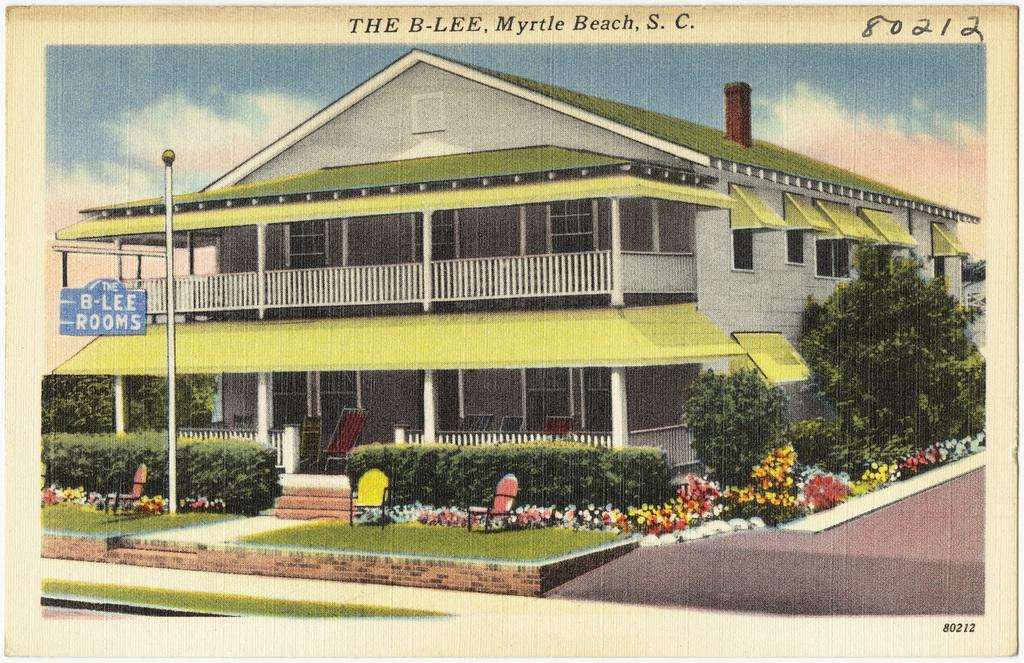What can be seen on the poster in the image? The facts do not specify what is on the poster, so we cannot answer this question definitively. What type of structure is visible in the image? There is a building in the image. What type of vegetation can be seen in the image? There are plants, trees, and flowers in the image. What is visible in the sky in the image? The sky is visible in the image. What objects are present in the image? The facts mention that there are objects in the image, but they do not specify what they are. What type of text is present in the image? The facts mention that there is text in the image, but they do not specify what it says. Is there any sleet visible in the image? There is no mention of sleet in the provided facts, so we cannot answer this question definitively. 